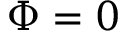<formula> <loc_0><loc_0><loc_500><loc_500>\Phi = 0</formula> 